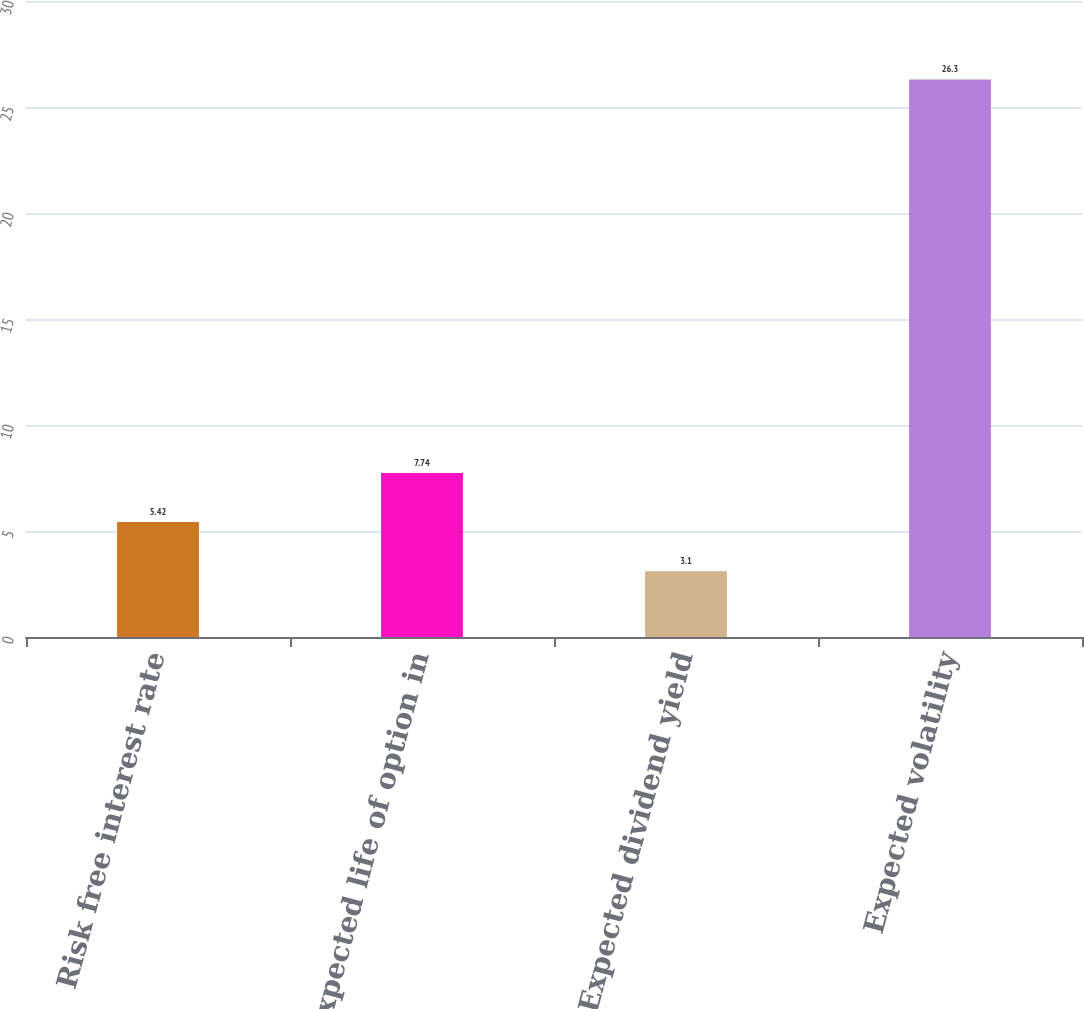<chart> <loc_0><loc_0><loc_500><loc_500><bar_chart><fcel>Risk free interest rate<fcel>Expected life of option in<fcel>Expected dividend yield<fcel>Expected volatility<nl><fcel>5.42<fcel>7.74<fcel>3.1<fcel>26.3<nl></chart> 